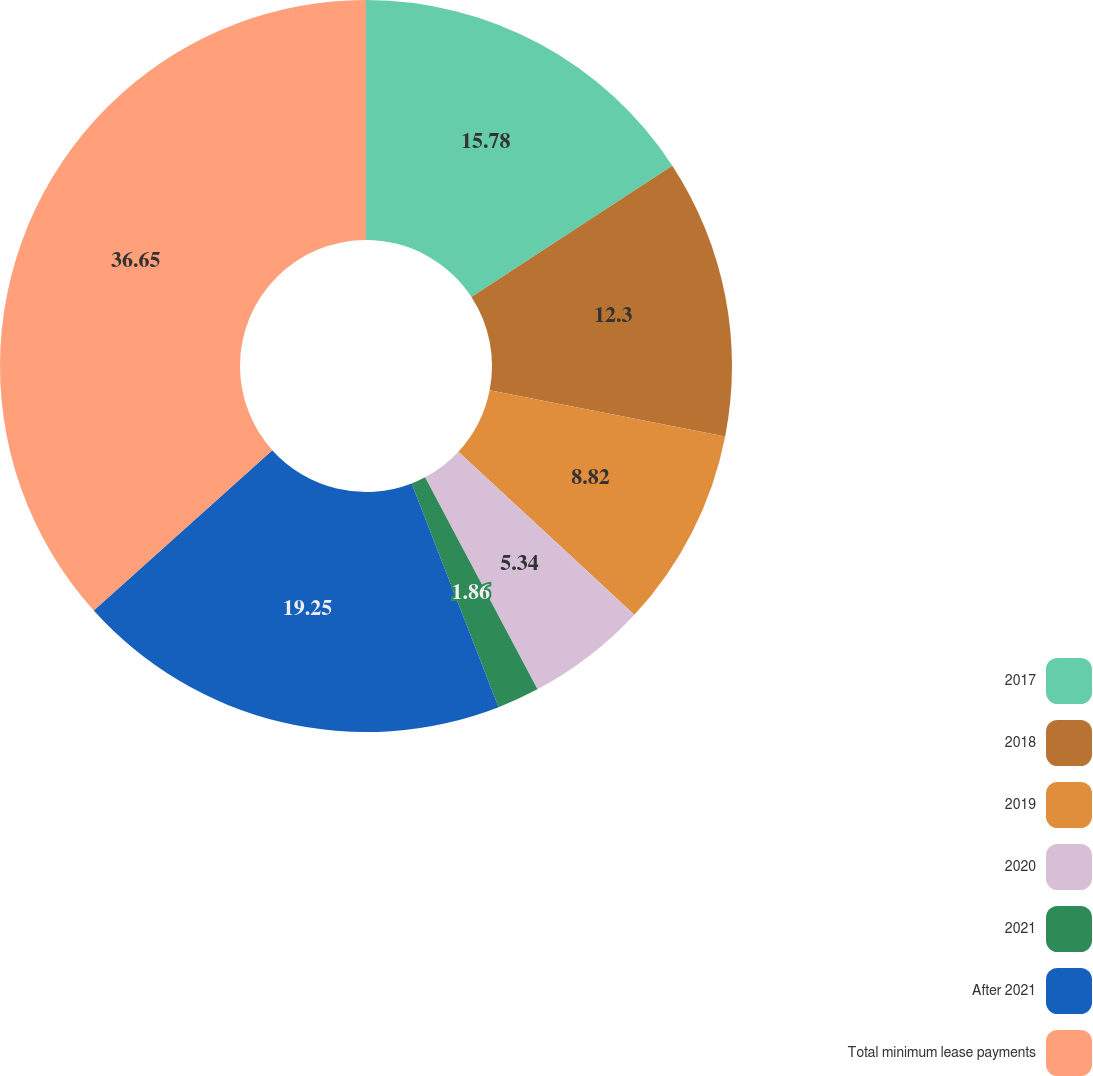Convert chart to OTSL. <chart><loc_0><loc_0><loc_500><loc_500><pie_chart><fcel>2017<fcel>2018<fcel>2019<fcel>2020<fcel>2021<fcel>After 2021<fcel>Total minimum lease payments<nl><fcel>15.78%<fcel>12.3%<fcel>8.82%<fcel>5.34%<fcel>1.86%<fcel>19.25%<fcel>36.65%<nl></chart> 